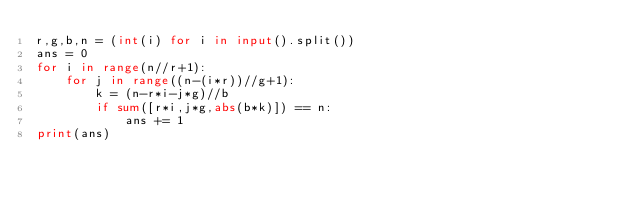Convert code to text. <code><loc_0><loc_0><loc_500><loc_500><_Python_>r,g,b,n = (int(i) for i in input().split())
ans = 0
for i in range(n//r+1):
    for j in range((n-(i*r))//g+1):
        k = (n-r*i-j*g)//b
        if sum([r*i,j*g,abs(b*k)]) == n:
            ans += 1
print(ans)
</code> 